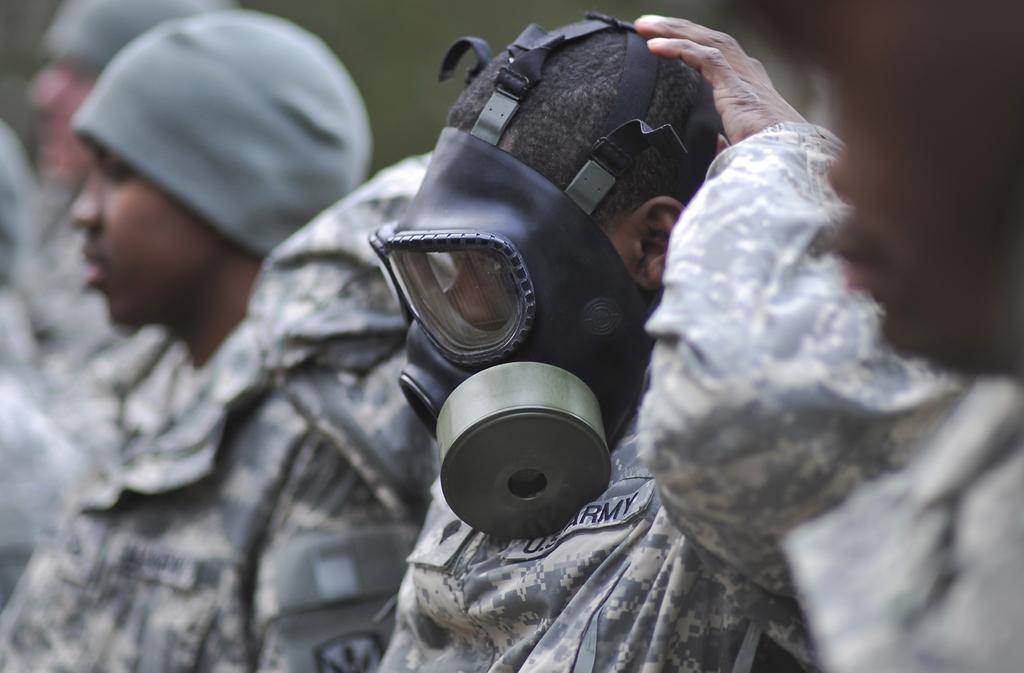Describe this image in one or two sentences. In this picture, we can see a few people with head-wear, and we can see the blurred background. 